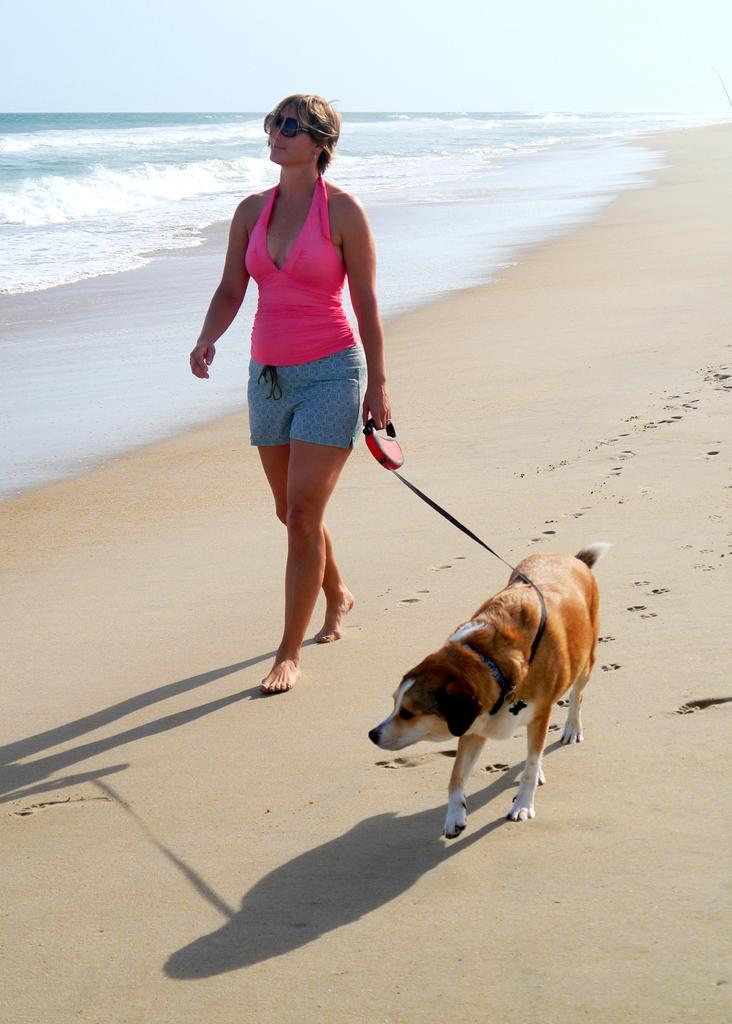Who is present in the image? There is a woman in the image. What is the woman doing? The woman is walking. Where is the location of the image? The location is the beach side. Is there any other living being in the image? Yes, there is a dog in the image. What is the dog doing? The dog is also walking. What can be seen in the background of the image? The beach is visible in the image. What is the secretary doing in the image? There is no secretary present in the image. How long does it take for the woman to walk a minute in the image? The image is a still photograph, so it does not show the passage of time or the duration of the woman's walk. 